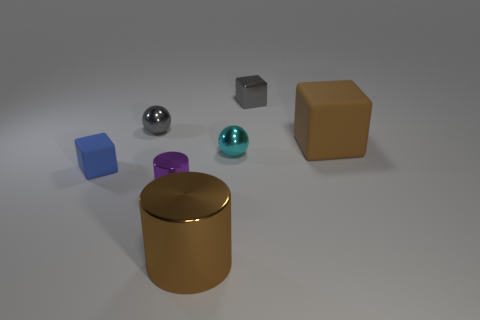Add 3 large cyan things. How many objects exist? 10 Subtract all green cubes. Subtract all blue balls. How many cubes are left? 3 Subtract all spheres. How many objects are left? 5 Subtract all big gray shiny cylinders. Subtract all purple cylinders. How many objects are left? 6 Add 7 small purple shiny things. How many small purple shiny things are left? 8 Add 7 small purple cylinders. How many small purple cylinders exist? 8 Subtract 1 brown cylinders. How many objects are left? 6 